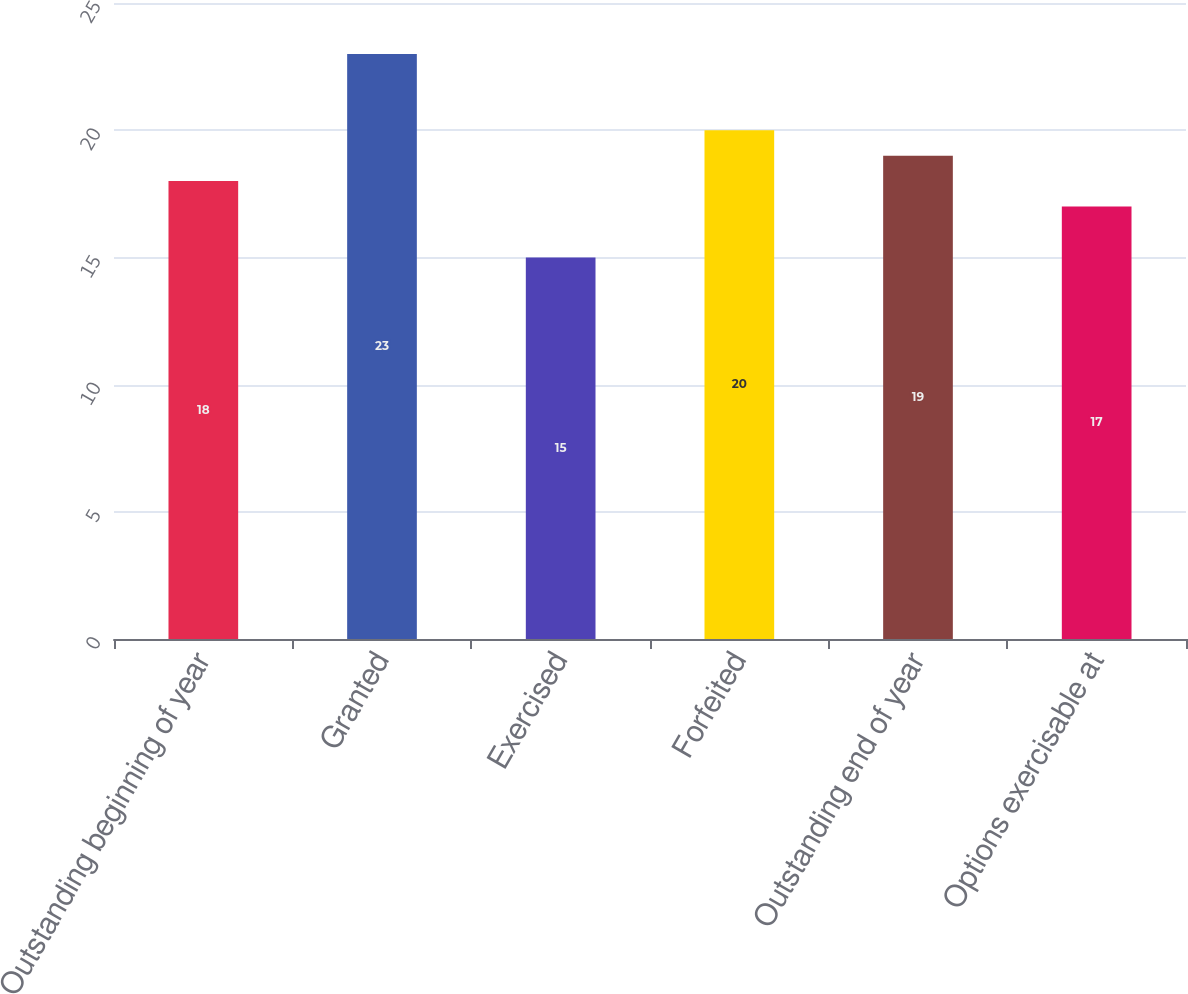<chart> <loc_0><loc_0><loc_500><loc_500><bar_chart><fcel>Outstanding beginning of year<fcel>Granted<fcel>Exercised<fcel>Forfeited<fcel>Outstanding end of year<fcel>Options exercisable at<nl><fcel>18<fcel>23<fcel>15<fcel>20<fcel>19<fcel>17<nl></chart> 